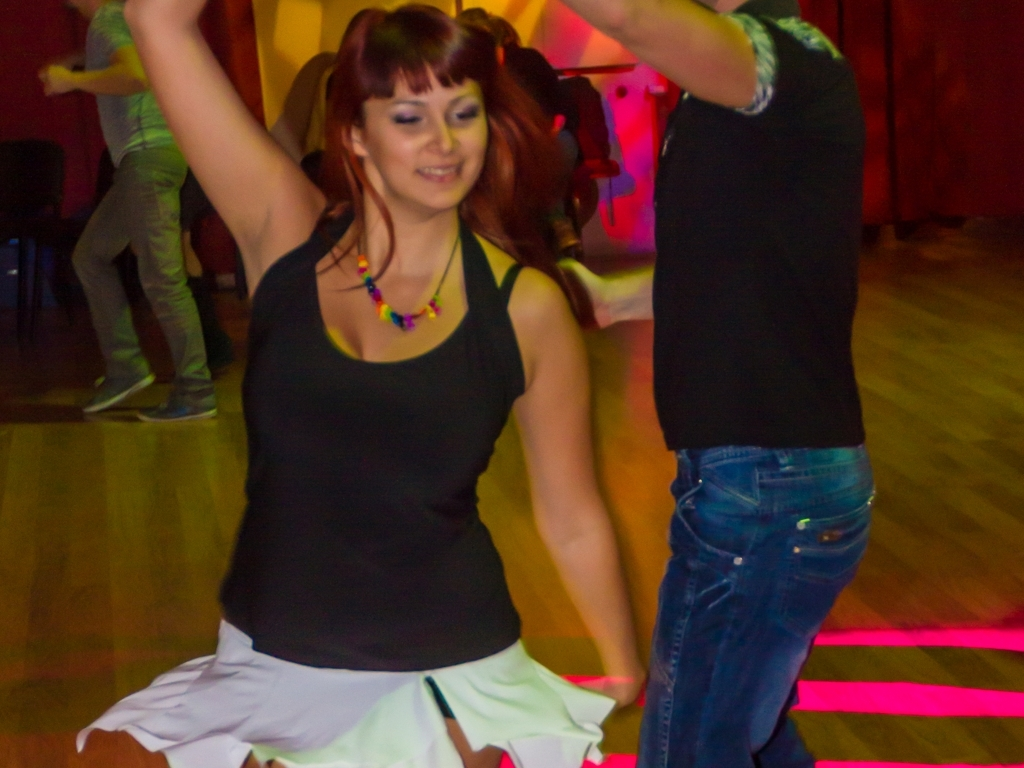Could you describe the attire of the individuals? Certainly. The woman in the foreground is wearing a casual, sleeveless black top paired with a lightweight, flowing white skirt that is slightly blurred from movement. She has accessorized with a colorful necklace. The man in the background, who's partially visible, seems to be wearing a simple dark short-sleeved shirt and denim jeans. 